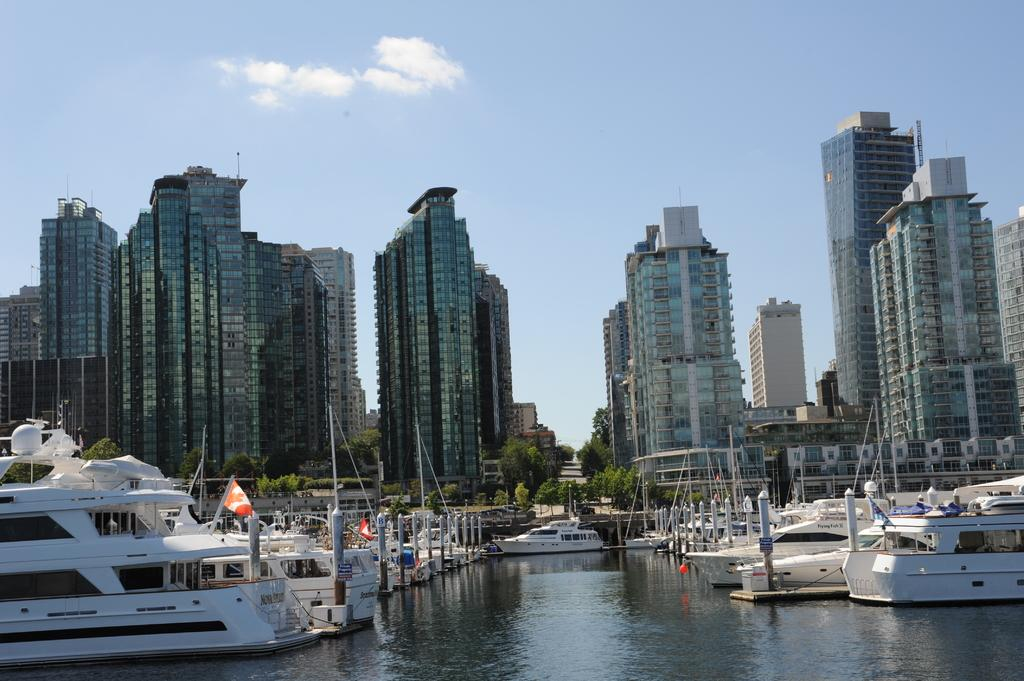What is the main subject of the image? The main subject of the image is ships. Where are the ships located in the image? The ships are parked on the water. What type of natural environment is visible in the image? There are trees visible in the image. What type of man-made structures can be seen in the image? There are buildings in the image. What type of net is being used to catch fish in the image? There is no net visible in the image, and no fishing activity is taking place. What time of day is it in the image, based on the hour? The provided facts do not mention the time of day or any specific hour, so it cannot be determined from the image. 